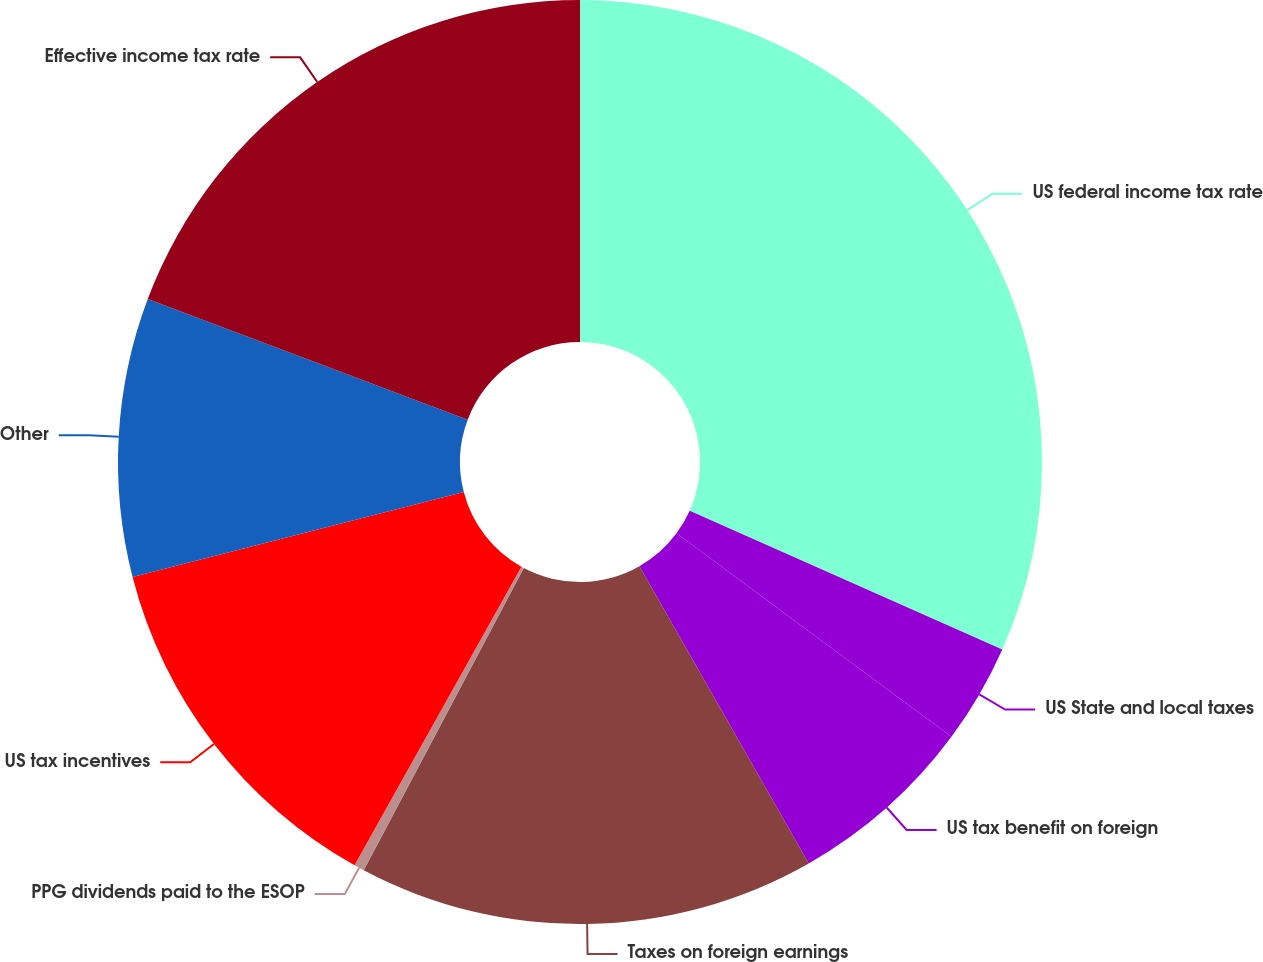<chart> <loc_0><loc_0><loc_500><loc_500><pie_chart><fcel>US federal income tax rate<fcel>US State and local taxes<fcel>US tax benefit on foreign<fcel>Taxes on foreign earnings<fcel>PPG dividends paid to the ESOP<fcel>US tax incentives<fcel>Other<fcel>Effective income tax rate<nl><fcel>31.65%<fcel>3.49%<fcel>6.62%<fcel>16.0%<fcel>0.36%<fcel>12.88%<fcel>9.75%<fcel>19.26%<nl></chart> 